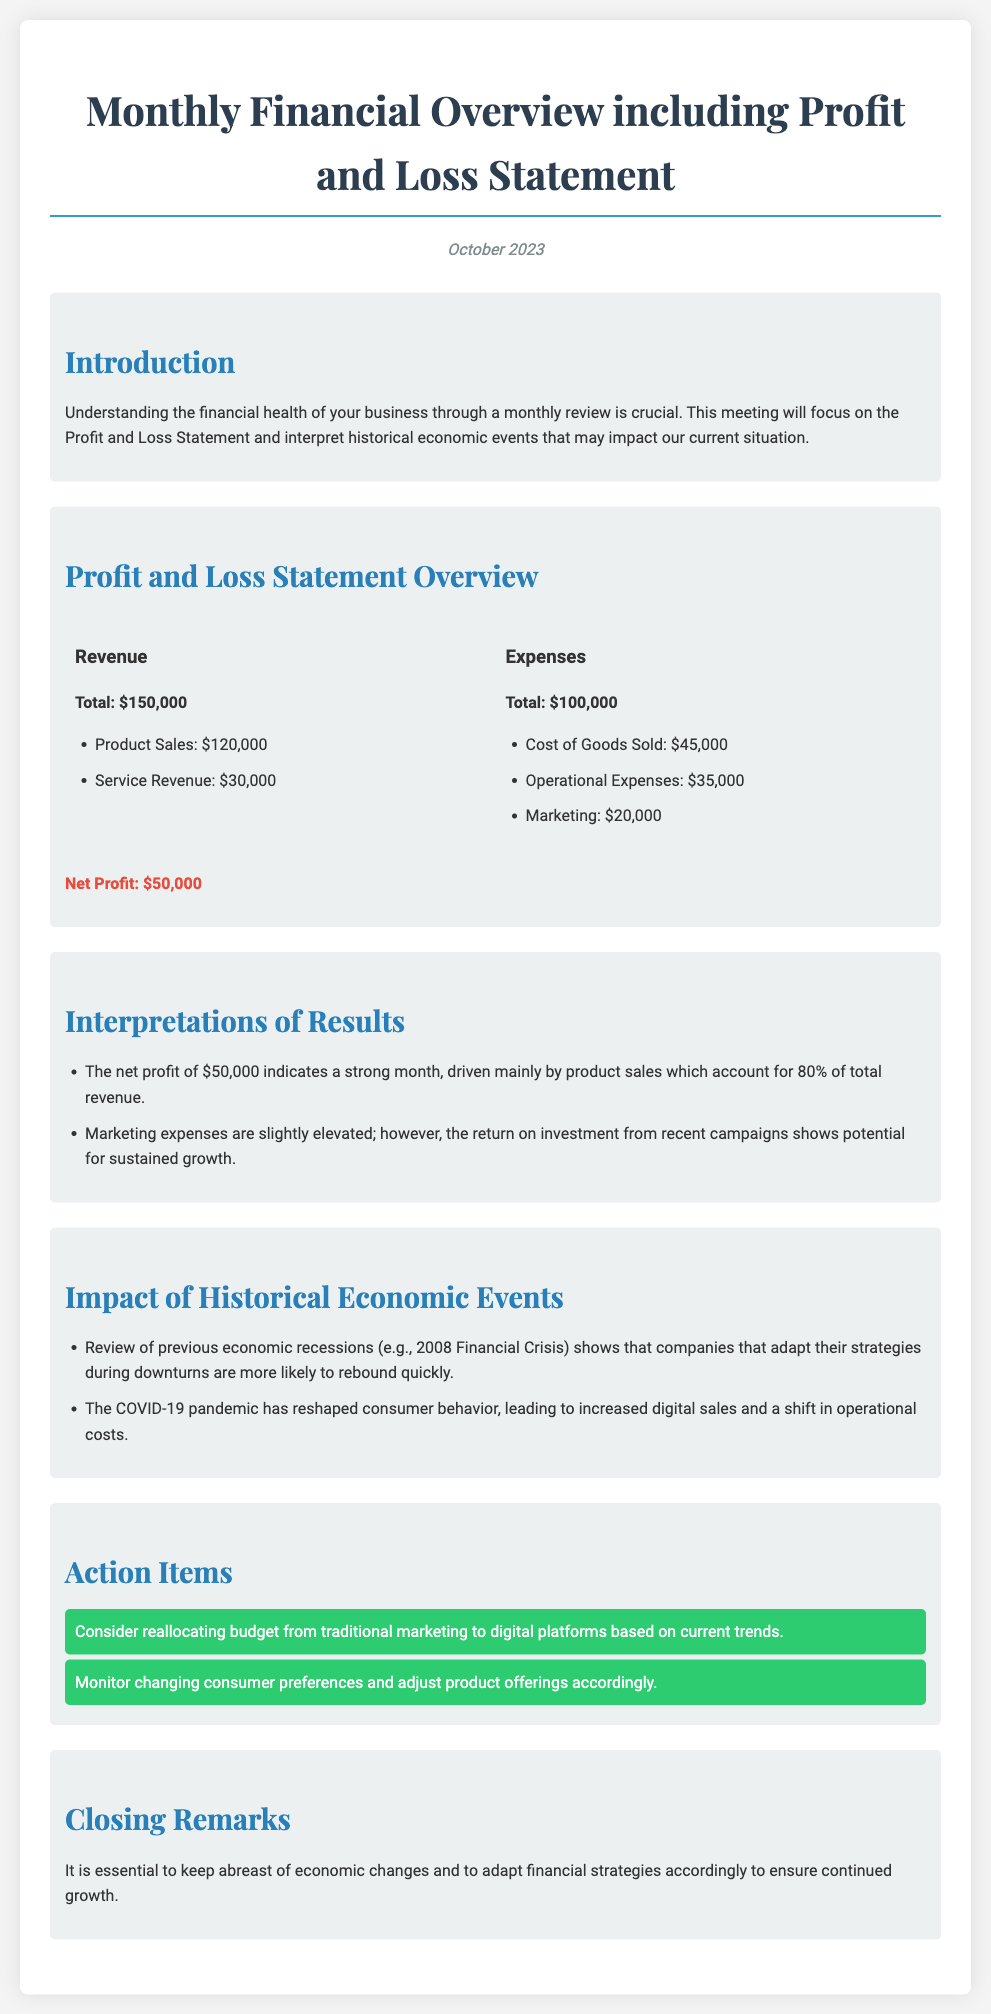What is the total revenue? The total revenue is provided in the Profit and Loss Statement overview, which is $150,000.
Answer: $150,000 What are the operational expenses? The operational expenses are listed in the expenses section of the Profit and Loss Statement, which totals $35,000.
Answer: $35,000 What percentage of total revenue comes from product sales? Product sales amount to $120,000, which accounts for 80% of total revenue.
Answer: 80% What was the net profit? The net profit is highlighted in the document and is calculated as total revenue minus total expenses, which equals $50,000.
Answer: $50,000 What does the document suggest about marketing expenses? The document indicates that marketing expenses are slightly elevated but shows potential for sustained growth from investments.
Answer: Elevated What historical event is referenced as influencing business strategy? The document mentions the 2008 Financial Crisis as a significant historical economic event affecting strategies.
Answer: 2008 Financial Crisis What action item is suggested related to marketing? The document suggests reallocating budget from traditional marketing to digital platforms based on current trends.
Answer: Reallocate budget How has consumer behavior changed according to the document? The document states that the COVID-19 pandemic has led to increased digital sales and a shift in operational costs reflecting changes in consumer behavior.
Answer: Increased digital sales What is the date of the monthly financial overview? The date is provided at the beginning of the document, indicating when the overview was created: October 2023.
Answer: October 2023 What is the total expenses amount? The total expenses are summarized in the financial overview section, which totals $100,000.
Answer: $100,000 